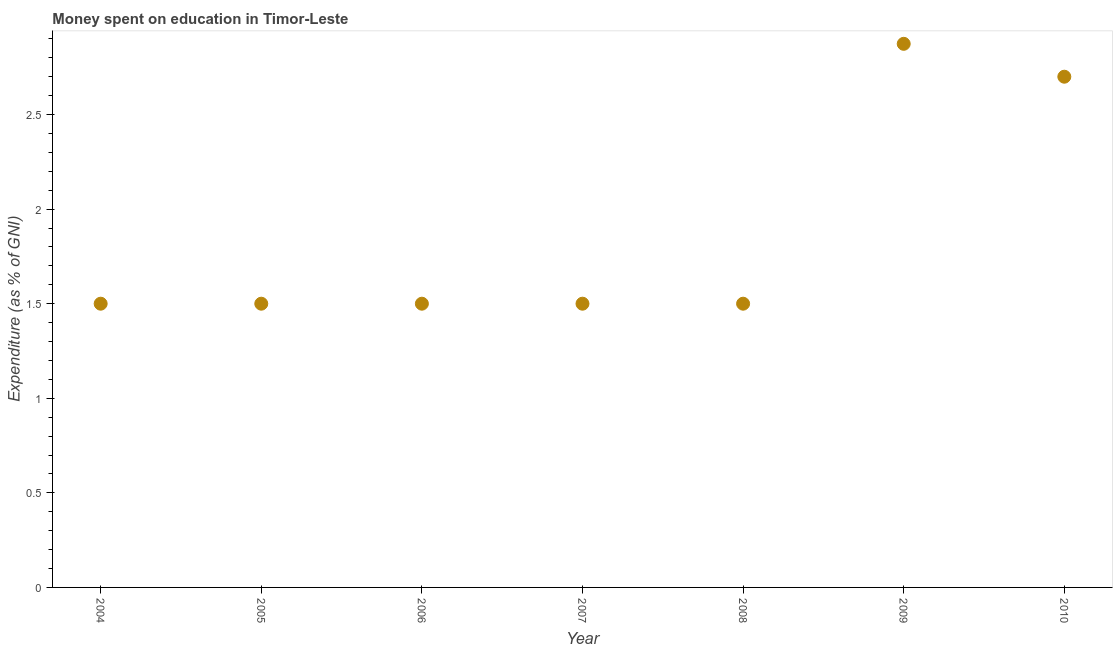What is the expenditure on education in 2006?
Provide a succinct answer. 1.5. Across all years, what is the maximum expenditure on education?
Provide a succinct answer. 2.87. In which year was the expenditure on education minimum?
Keep it short and to the point. 2004. What is the sum of the expenditure on education?
Keep it short and to the point. 13.07. What is the difference between the expenditure on education in 2007 and 2009?
Offer a very short reply. -1.37. What is the average expenditure on education per year?
Your answer should be compact. 1.87. What is the median expenditure on education?
Your answer should be compact. 1.5. In how many years, is the expenditure on education greater than 0.2 %?
Provide a succinct answer. 7. Do a majority of the years between 2004 and 2008 (inclusive) have expenditure on education greater than 0.1 %?
Provide a succinct answer. Yes. What is the ratio of the expenditure on education in 2006 to that in 2008?
Your answer should be very brief. 1. Is the expenditure on education in 2005 less than that in 2009?
Make the answer very short. Yes. Is the difference between the expenditure on education in 2006 and 2007 greater than the difference between any two years?
Provide a succinct answer. No. What is the difference between the highest and the second highest expenditure on education?
Offer a very short reply. 0.17. Is the sum of the expenditure on education in 2006 and 2010 greater than the maximum expenditure on education across all years?
Your response must be concise. Yes. What is the difference between the highest and the lowest expenditure on education?
Give a very brief answer. 1.37. Does the expenditure on education monotonically increase over the years?
Keep it short and to the point. No. How many dotlines are there?
Make the answer very short. 1. Does the graph contain grids?
Keep it short and to the point. No. What is the title of the graph?
Make the answer very short. Money spent on education in Timor-Leste. What is the label or title of the X-axis?
Make the answer very short. Year. What is the label or title of the Y-axis?
Ensure brevity in your answer.  Expenditure (as % of GNI). What is the Expenditure (as % of GNI) in 2004?
Ensure brevity in your answer.  1.5. What is the Expenditure (as % of GNI) in 2007?
Make the answer very short. 1.5. What is the Expenditure (as % of GNI) in 2009?
Offer a very short reply. 2.87. What is the difference between the Expenditure (as % of GNI) in 2004 and 2005?
Your answer should be compact. 0. What is the difference between the Expenditure (as % of GNI) in 2004 and 2008?
Provide a succinct answer. 0. What is the difference between the Expenditure (as % of GNI) in 2004 and 2009?
Your answer should be very brief. -1.37. What is the difference between the Expenditure (as % of GNI) in 2004 and 2010?
Provide a short and direct response. -1.2. What is the difference between the Expenditure (as % of GNI) in 2005 and 2007?
Offer a terse response. 0. What is the difference between the Expenditure (as % of GNI) in 2005 and 2009?
Keep it short and to the point. -1.37. What is the difference between the Expenditure (as % of GNI) in 2006 and 2007?
Your response must be concise. 0. What is the difference between the Expenditure (as % of GNI) in 2006 and 2009?
Offer a terse response. -1.37. What is the difference between the Expenditure (as % of GNI) in 2007 and 2009?
Give a very brief answer. -1.37. What is the difference between the Expenditure (as % of GNI) in 2008 and 2009?
Provide a succinct answer. -1.37. What is the difference between the Expenditure (as % of GNI) in 2008 and 2010?
Make the answer very short. -1.2. What is the difference between the Expenditure (as % of GNI) in 2009 and 2010?
Your answer should be compact. 0.17. What is the ratio of the Expenditure (as % of GNI) in 2004 to that in 2006?
Ensure brevity in your answer.  1. What is the ratio of the Expenditure (as % of GNI) in 2004 to that in 2008?
Make the answer very short. 1. What is the ratio of the Expenditure (as % of GNI) in 2004 to that in 2009?
Provide a short and direct response. 0.52. What is the ratio of the Expenditure (as % of GNI) in 2004 to that in 2010?
Ensure brevity in your answer.  0.56. What is the ratio of the Expenditure (as % of GNI) in 2005 to that in 2009?
Provide a succinct answer. 0.52. What is the ratio of the Expenditure (as % of GNI) in 2005 to that in 2010?
Provide a short and direct response. 0.56. What is the ratio of the Expenditure (as % of GNI) in 2006 to that in 2009?
Offer a terse response. 0.52. What is the ratio of the Expenditure (as % of GNI) in 2006 to that in 2010?
Offer a very short reply. 0.56. What is the ratio of the Expenditure (as % of GNI) in 2007 to that in 2008?
Your response must be concise. 1. What is the ratio of the Expenditure (as % of GNI) in 2007 to that in 2009?
Provide a short and direct response. 0.52. What is the ratio of the Expenditure (as % of GNI) in 2007 to that in 2010?
Your answer should be very brief. 0.56. What is the ratio of the Expenditure (as % of GNI) in 2008 to that in 2009?
Offer a terse response. 0.52. What is the ratio of the Expenditure (as % of GNI) in 2008 to that in 2010?
Your answer should be very brief. 0.56. What is the ratio of the Expenditure (as % of GNI) in 2009 to that in 2010?
Keep it short and to the point. 1.06. 